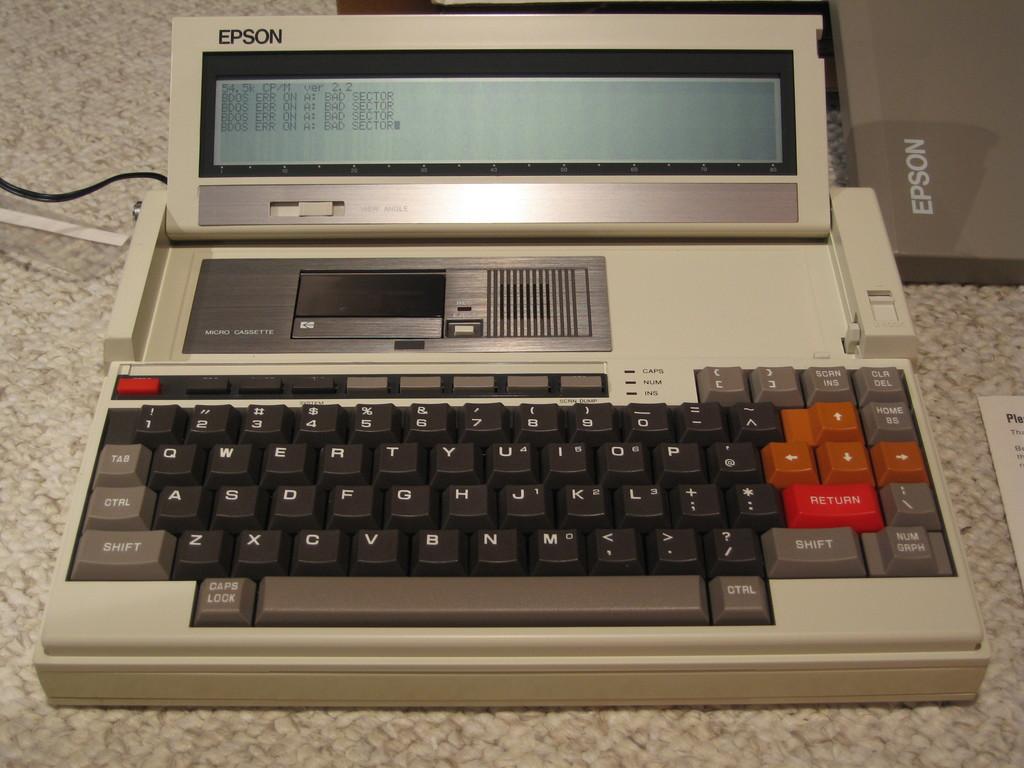Which company made this machine?
Give a very brief answer. Epson. What is the function of the red button on the right?
Give a very brief answer. Return. 